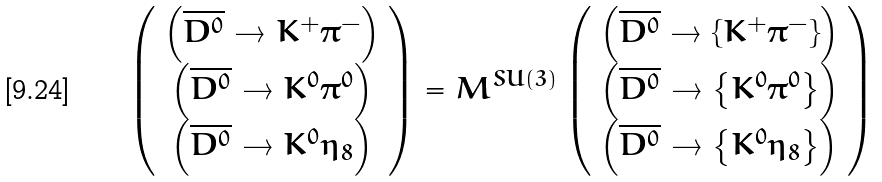Convert formula to latex. <formula><loc_0><loc_0><loc_500><loc_500>\left ( \begin{array} { c } \left ( \overline { D ^ { 0 } } \rightarrow K ^ { + } \pi ^ { - } \right ) \\ \left ( \overline { D ^ { 0 } } \rightarrow K ^ { 0 } \pi ^ { 0 } \right ) \\ \left ( \overline { D ^ { 0 } } \rightarrow K ^ { 0 } \eta _ { 8 } \right ) \end{array} \right ) = M ^ { S U ( 3 ) } \left ( \begin{array} { c } \left ( \overline { D ^ { 0 } } \rightarrow \left \{ K ^ { + } \pi ^ { - } \right \} \right ) \\ \left ( \overline { D ^ { 0 } } \rightarrow \left \{ K ^ { 0 } \pi ^ { 0 } \right \} \right ) \\ \left ( \overline { D ^ { 0 } } \rightarrow \left \{ K ^ { 0 } \eta _ { 8 } \right \} \right ) \end{array} \right )</formula> 